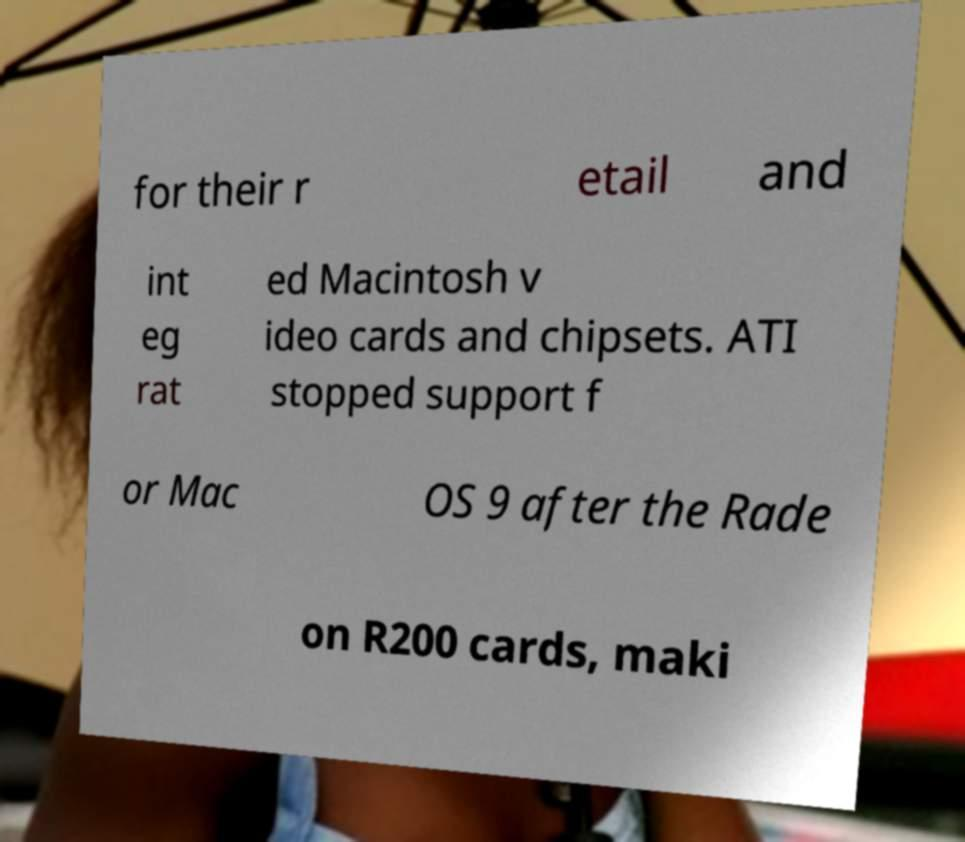Could you assist in decoding the text presented in this image and type it out clearly? for their r etail and int eg rat ed Macintosh v ideo cards and chipsets. ATI stopped support f or Mac OS 9 after the Rade on R200 cards, maki 